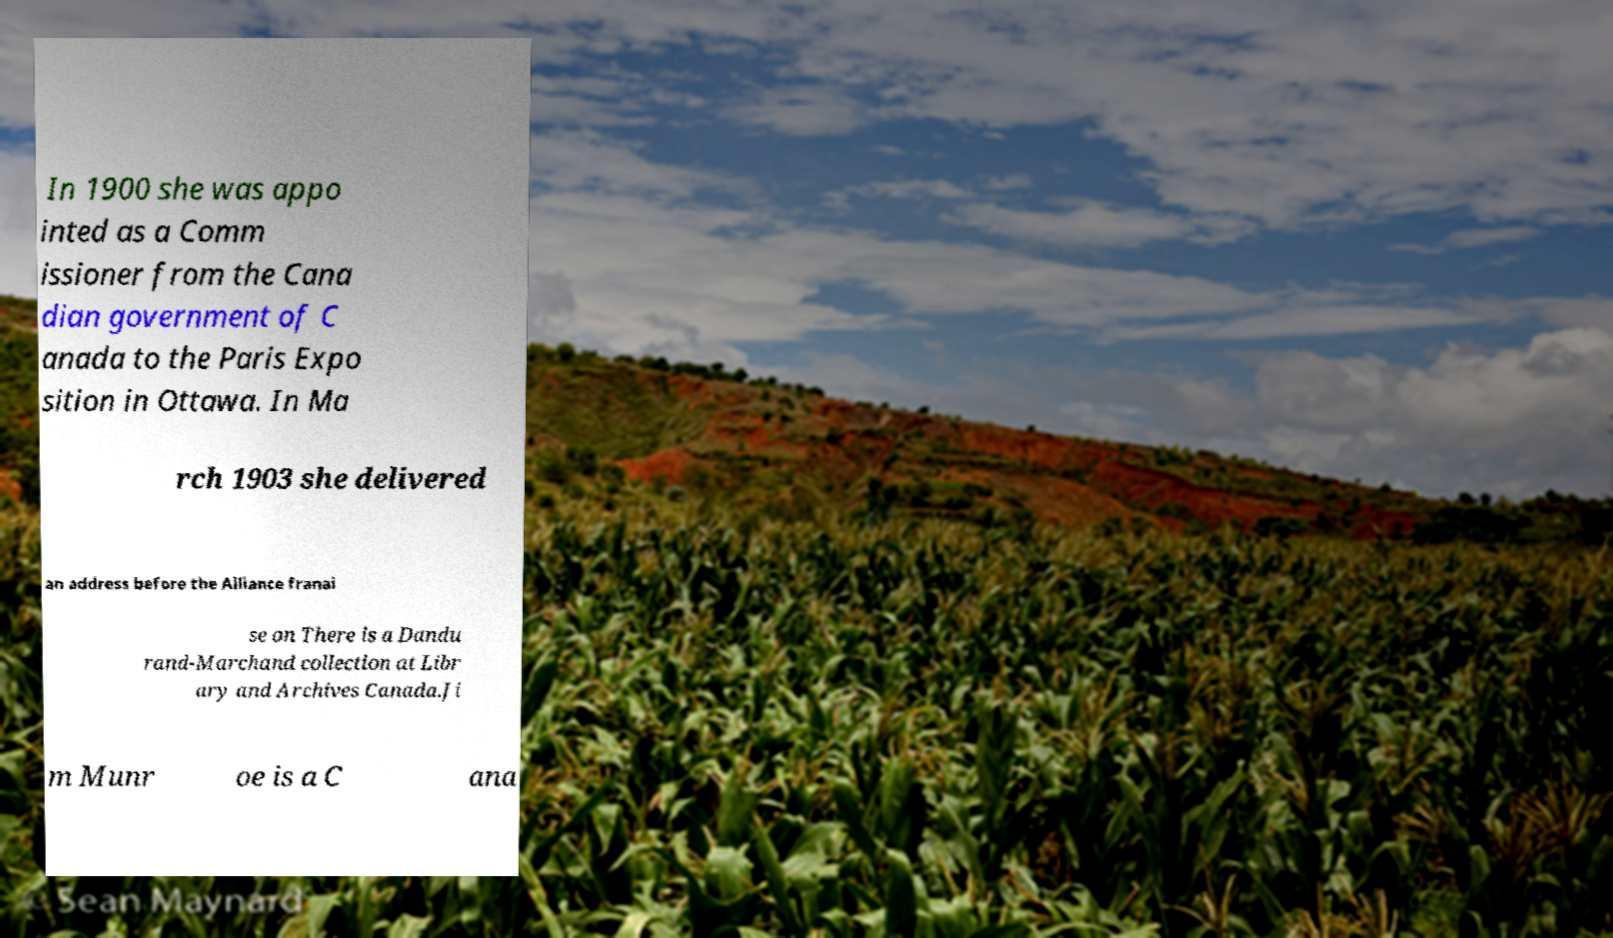I need the written content from this picture converted into text. Can you do that? In 1900 she was appo inted as a Comm issioner from the Cana dian government of C anada to the Paris Expo sition in Ottawa. In Ma rch 1903 she delivered an address before the Alliance franai se on There is a Dandu rand-Marchand collection at Libr ary and Archives Canada.Ji m Munr oe is a C ana 